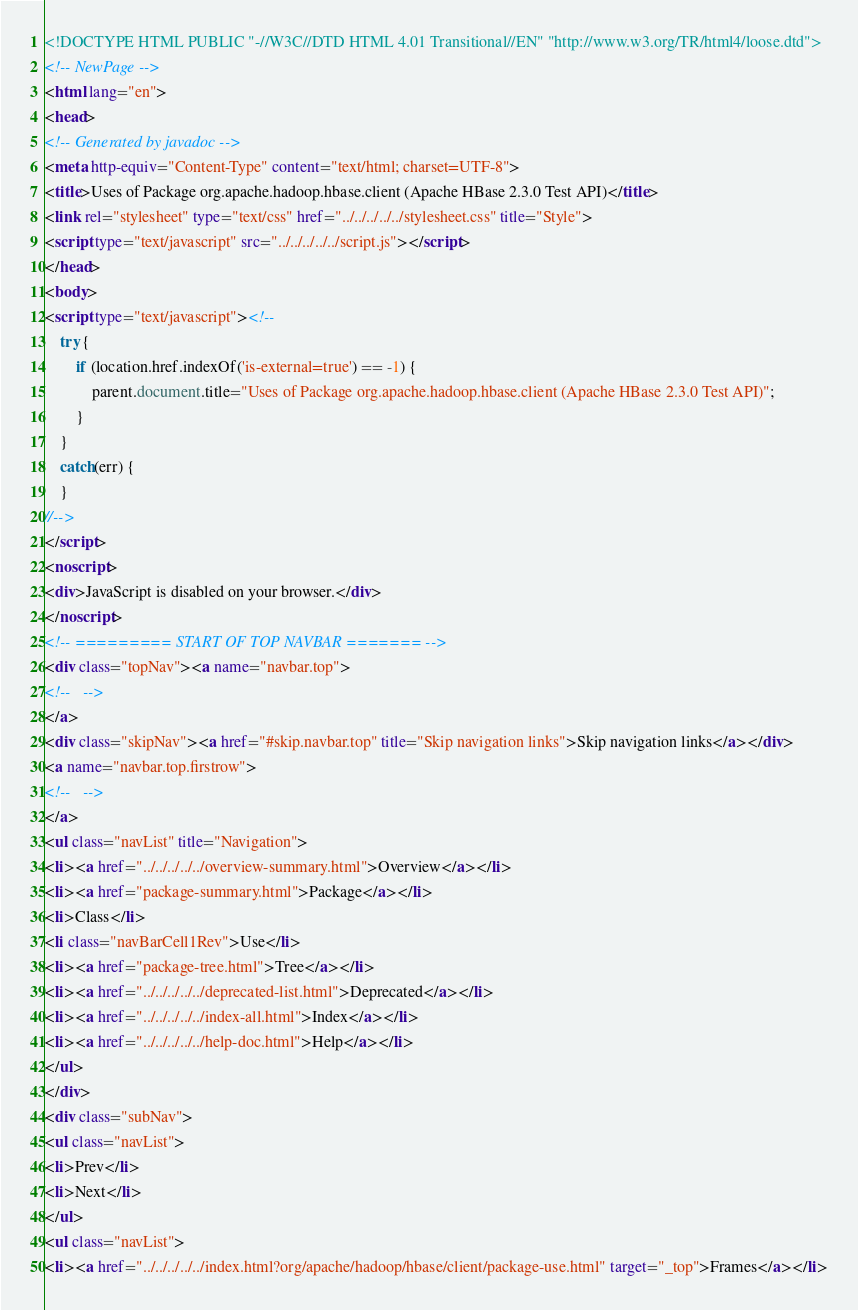Convert code to text. <code><loc_0><loc_0><loc_500><loc_500><_HTML_><!DOCTYPE HTML PUBLIC "-//W3C//DTD HTML 4.01 Transitional//EN" "http://www.w3.org/TR/html4/loose.dtd">
<!-- NewPage -->
<html lang="en">
<head>
<!-- Generated by javadoc -->
<meta http-equiv="Content-Type" content="text/html; charset=UTF-8">
<title>Uses of Package org.apache.hadoop.hbase.client (Apache HBase 2.3.0 Test API)</title>
<link rel="stylesheet" type="text/css" href="../../../../../stylesheet.css" title="Style">
<script type="text/javascript" src="../../../../../script.js"></script>
</head>
<body>
<script type="text/javascript"><!--
    try {
        if (location.href.indexOf('is-external=true') == -1) {
            parent.document.title="Uses of Package org.apache.hadoop.hbase.client (Apache HBase 2.3.0 Test API)";
        }
    }
    catch(err) {
    }
//-->
</script>
<noscript>
<div>JavaScript is disabled on your browser.</div>
</noscript>
<!-- ========= START OF TOP NAVBAR ======= -->
<div class="topNav"><a name="navbar.top">
<!--   -->
</a>
<div class="skipNav"><a href="#skip.navbar.top" title="Skip navigation links">Skip navigation links</a></div>
<a name="navbar.top.firstrow">
<!--   -->
</a>
<ul class="navList" title="Navigation">
<li><a href="../../../../../overview-summary.html">Overview</a></li>
<li><a href="package-summary.html">Package</a></li>
<li>Class</li>
<li class="navBarCell1Rev">Use</li>
<li><a href="package-tree.html">Tree</a></li>
<li><a href="../../../../../deprecated-list.html">Deprecated</a></li>
<li><a href="../../../../../index-all.html">Index</a></li>
<li><a href="../../../../../help-doc.html">Help</a></li>
</ul>
</div>
<div class="subNav">
<ul class="navList">
<li>Prev</li>
<li>Next</li>
</ul>
<ul class="navList">
<li><a href="../../../../../index.html?org/apache/hadoop/hbase/client/package-use.html" target="_top">Frames</a></li></code> 